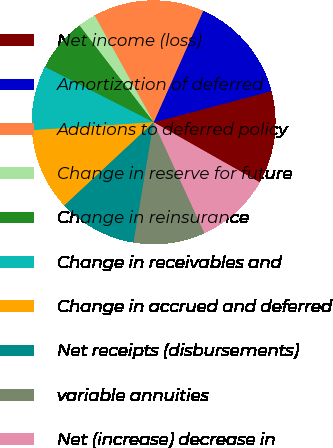Convert chart. <chart><loc_0><loc_0><loc_500><loc_500><pie_chart><fcel>Net income (loss)<fcel>Amortization of deferred<fcel>Additions to deferred policy<fcel>Change in reserve for future<fcel>Change in reinsurance<fcel>Change in receivables and<fcel>Change in accrued and deferred<fcel>Net receipts (disbursements)<fcel>variable annuities<fcel>Net (increase) decrease in<nl><fcel>12.32%<fcel>14.22%<fcel>14.69%<fcel>2.37%<fcel>7.11%<fcel>8.53%<fcel>10.9%<fcel>10.43%<fcel>9.48%<fcel>9.95%<nl></chart> 